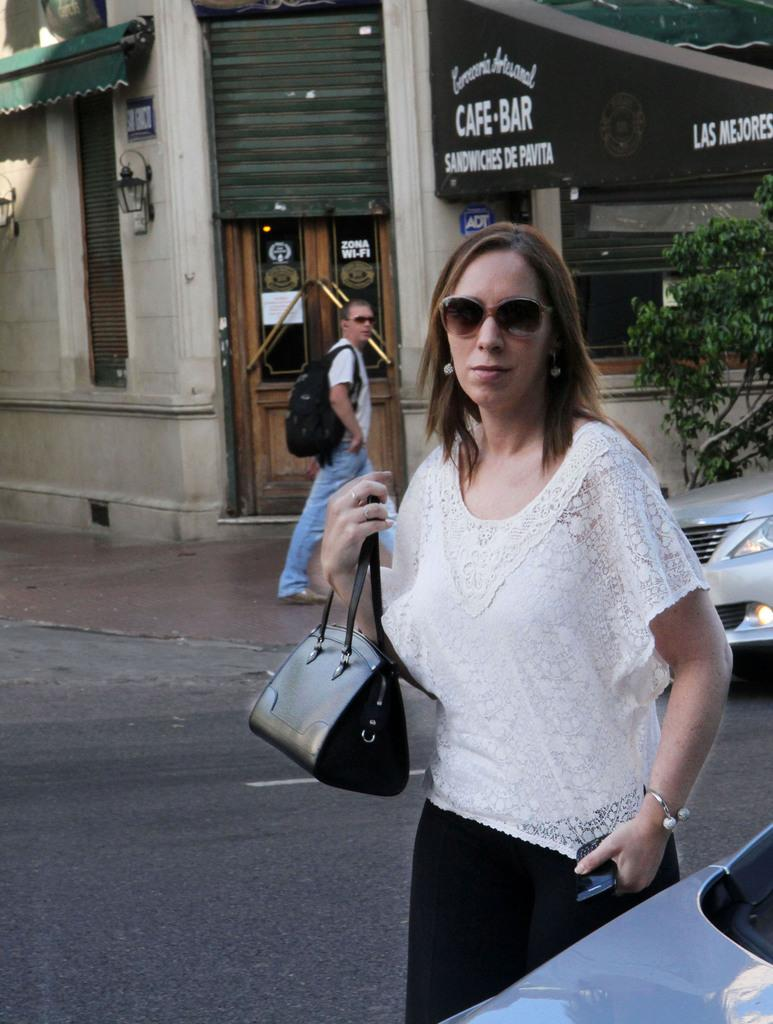Who is the main subject in the image? There is a lady in the center of the image. What is the lady holding in the image? The lady is holding a handbag. What can be seen in the background of the image? There is a building in the background of the image. What is the man in the image doing? There is a man walking in the image. What type of vegetation is present in the image? There is a tree in the image. What type of muscle is visible on the tree in the image? There is no muscle visible on the tree in the image, as trees do not have muscles. What mode of transport is being used by the lady in the image? The lady is not using any mode of transport in the image; she is standing and holding a handbag. 